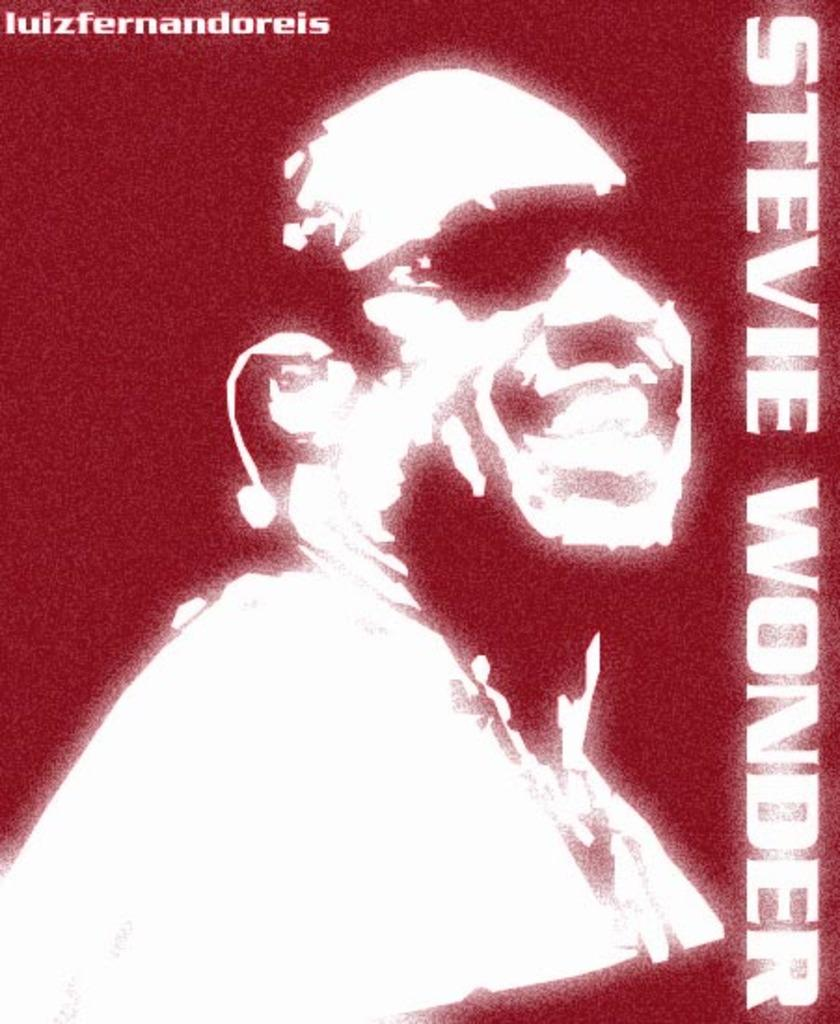Who is present in the image? There is a man in the image. What is the man's facial expression? The man is smiling. What accessory is the man wearing? The man is wearing glasses. What else can be seen in the image besides the man? There is text in the image. Can you describe the river flowing in the background of the image? There is no river present in the image; it only features a man, his facial expression, accessories, and text. 